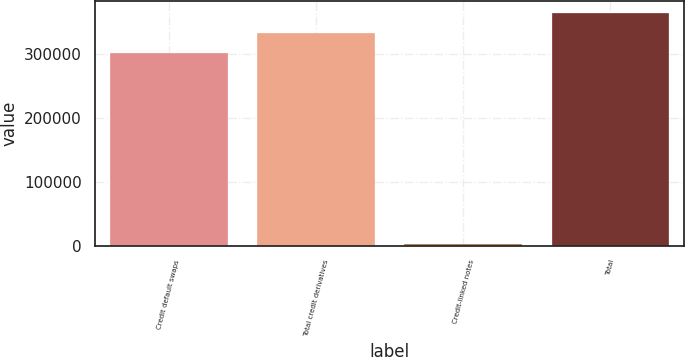Convert chart. <chart><loc_0><loc_0><loc_500><loc_500><bar_chart><fcel>Credit default swaps<fcel>Total credit derivatives<fcel>Credit-linked notes<fcel>Total<nl><fcel>302160<fcel>333386<fcel>1792<fcel>364611<nl></chart> 